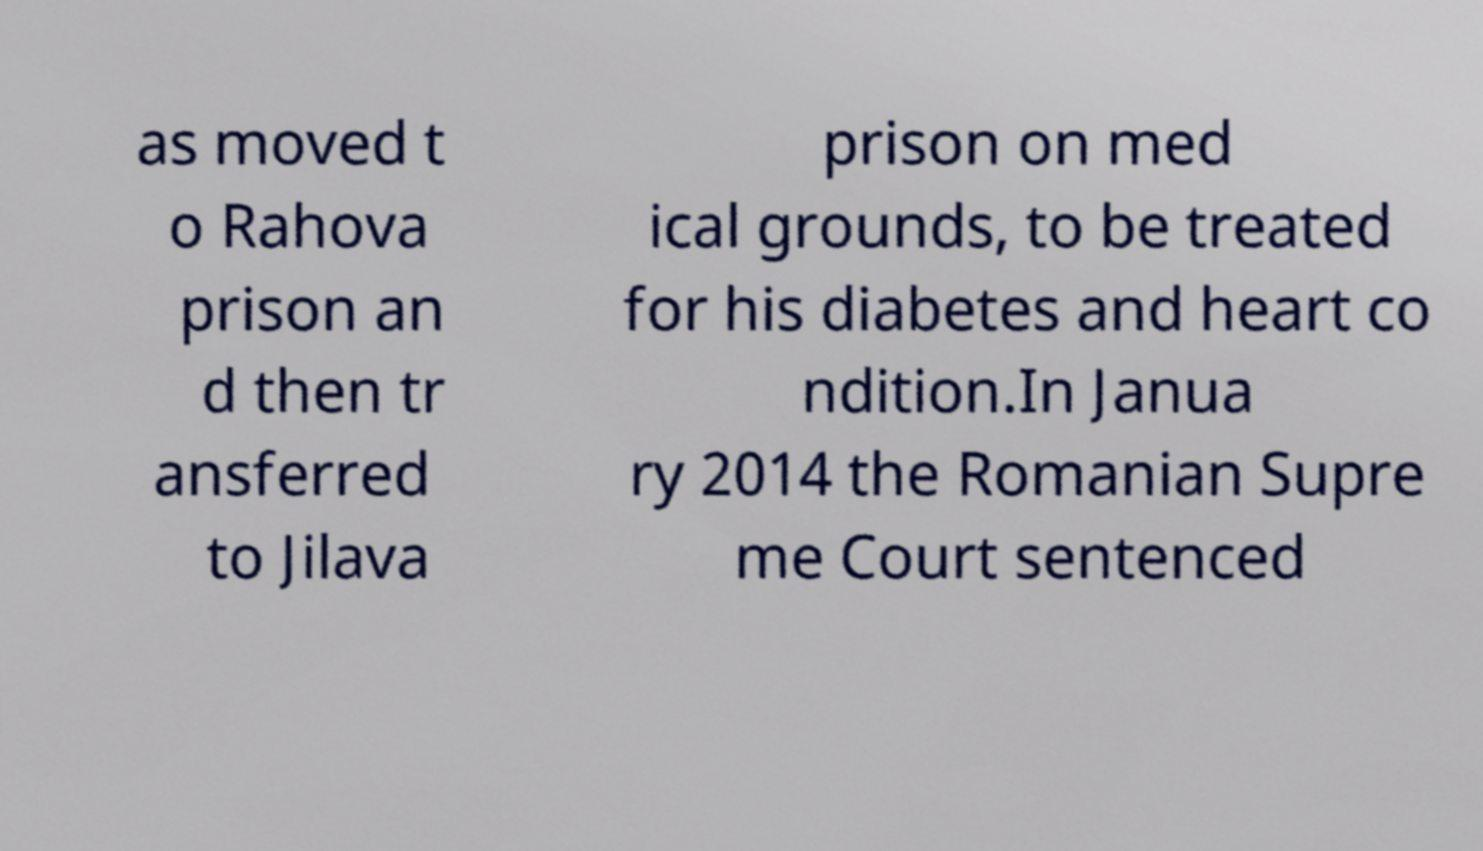Can you accurately transcribe the text from the provided image for me? as moved t o Rahova prison an d then tr ansferred to Jilava prison on med ical grounds, to be treated for his diabetes and heart co ndition.In Janua ry 2014 the Romanian Supre me Court sentenced 